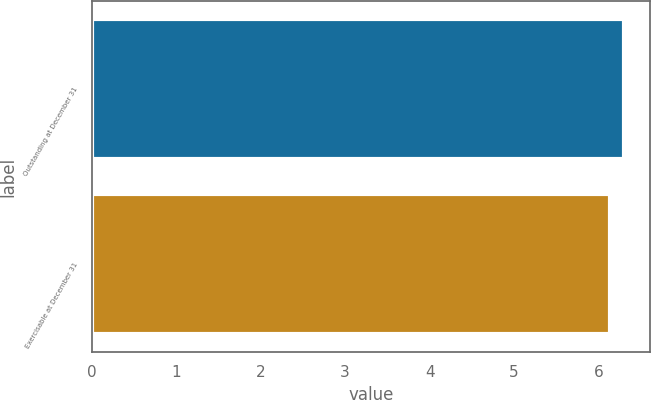Convert chart to OTSL. <chart><loc_0><loc_0><loc_500><loc_500><bar_chart><fcel>Outstanding at December 31<fcel>Exercisable at December 31<nl><fcel>6.3<fcel>6.14<nl></chart> 